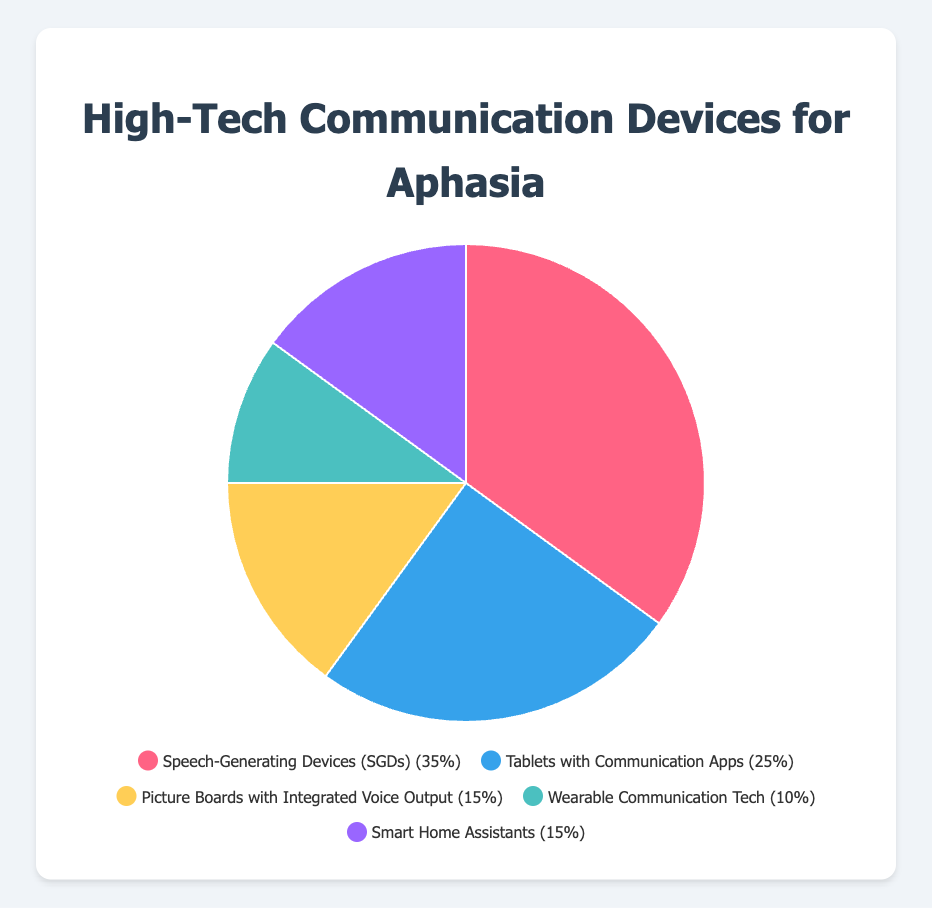What percentage of high-tech communication devices used are Tablets with Communication Apps? Look at the pie chart and find the segment labeled "Tablets with Communication Apps". The label or legend will show that these devices make up 25% of the total.
Answer: 25% Which type of high-tech communication device is the most commonly used? The largest segment in the pie chart represents the most commonly used device. Checking the chart, "Speech-Generating Devices (SGDs)" hold the largest segment at 35%.
Answer: Speech-Generating Devices (SGDs) What is the combined percentage of Picture Boards and Smart Home Assistants? Add the percentages of "Picture Boards with Integrated Voice Output" (15%) and "Smart Home Assistants" (15%). 15% + 15% = 30%
Answer: 30% Are Speech-Generating Devices (SGDs) more popular than Tablets with Communication Apps? Compare the percentage of each. SGDs are at 35% and Tablets with Communication Apps at 25%. Since 35% is greater than 25%, SGDs are more popular.
Answer: Yes What is the least used type of high-tech communication device? The smallest segment on the pie chart represents the least used device. "Wearable Communication Tech" is the smallest with 10%.
Answer: Wearable Communication Tech What is the total percentage of the three least popular devices? Identify the three devices with the smallest percentages, which are "Picture Boards" (15%), "Wearable Communication Tech" (10%), and "Smart Home Assistants" (15%). Add these up: 15% + 10% + 15% = 40%
Answer: 40% Is the percentage of Picture Boards equal to Smart Home Assistants? Compare their percentages. Both "Picture Boards" and "Smart Home Assistants" are at 15%. Since both have the same percentage, they are equal.
Answer: Yes What is the difference in percentage between the most and least used devices? Subtract the percentage of "Wearable Communication Tech" (10%) from "Speech-Generating Devices (SGDs)" (35%): 35% - 10% = 25%
Answer: 25% What percentage of devices are either Speech-Generating or Tablets with Communication Apps? Add the percentages of "Speech-Generating Devices (SGDs)" (35%) and "Tablets with Communication Apps" (25%): 35% + 25% = 60%
Answer: 60% Looking at the chart, which segment is represented by the color green? Visual cues indicate that "Wearable Communication Tech" is represented with a green segment.
Answer: Wearable Communication Tech 